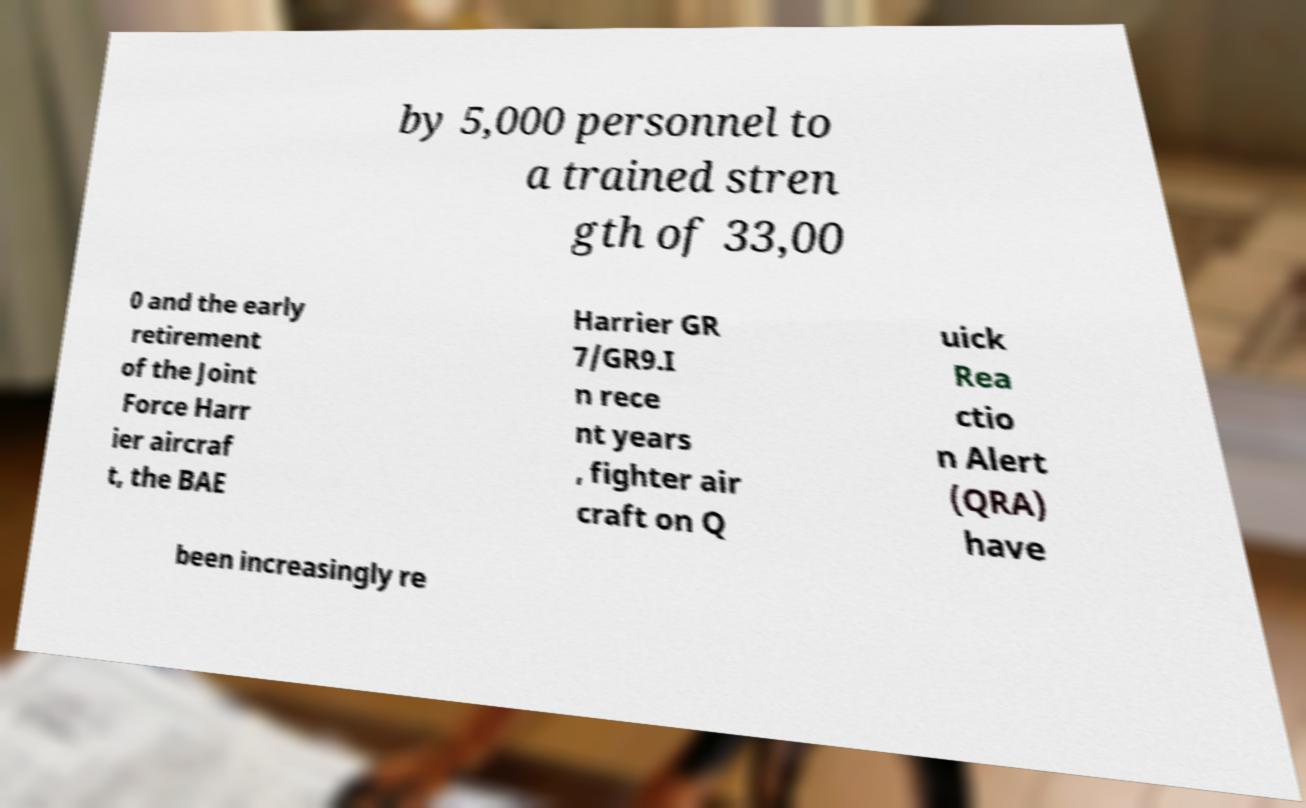For documentation purposes, I need the text within this image transcribed. Could you provide that? by 5,000 personnel to a trained stren gth of 33,00 0 and the early retirement of the Joint Force Harr ier aircraf t, the BAE Harrier GR 7/GR9.I n rece nt years , fighter air craft on Q uick Rea ctio n Alert (QRA) have been increasingly re 